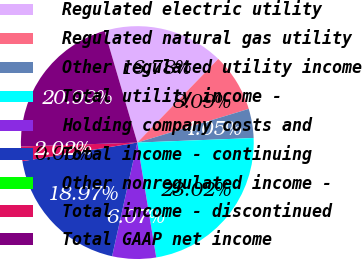<chart> <loc_0><loc_0><loc_500><loc_500><pie_chart><fcel>Regulated electric utility<fcel>Regulated natural gas utility<fcel>Other regulated utility income<fcel>Total utility income -<fcel>Holding company costs and<fcel>Total income - continuing<fcel>Other nonregulated income -<fcel>Total income - discontinued<fcel>Total GAAP net income<nl><fcel>16.78%<fcel>8.09%<fcel>4.05%<fcel>23.02%<fcel>6.07%<fcel>18.97%<fcel>0.0%<fcel>2.02%<fcel>20.99%<nl></chart> 